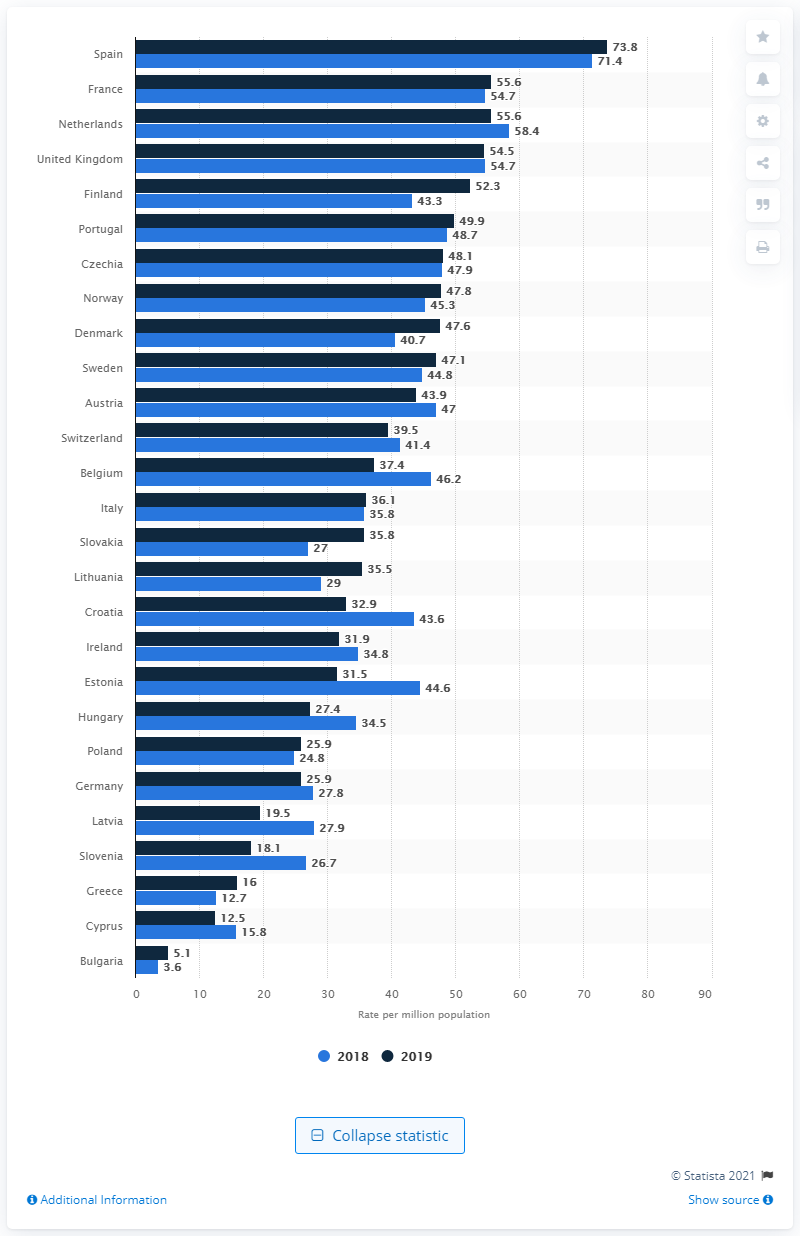Point out several critical features in this image. In 2019, Spain had the highest rate of kidney transplant procedures among all countries. France had the second highest rate of kidney transplants in 2019. In 2018, Spain's kidney transplant rate was 71.4 percent. Finland had the largest rate increase between the years. 